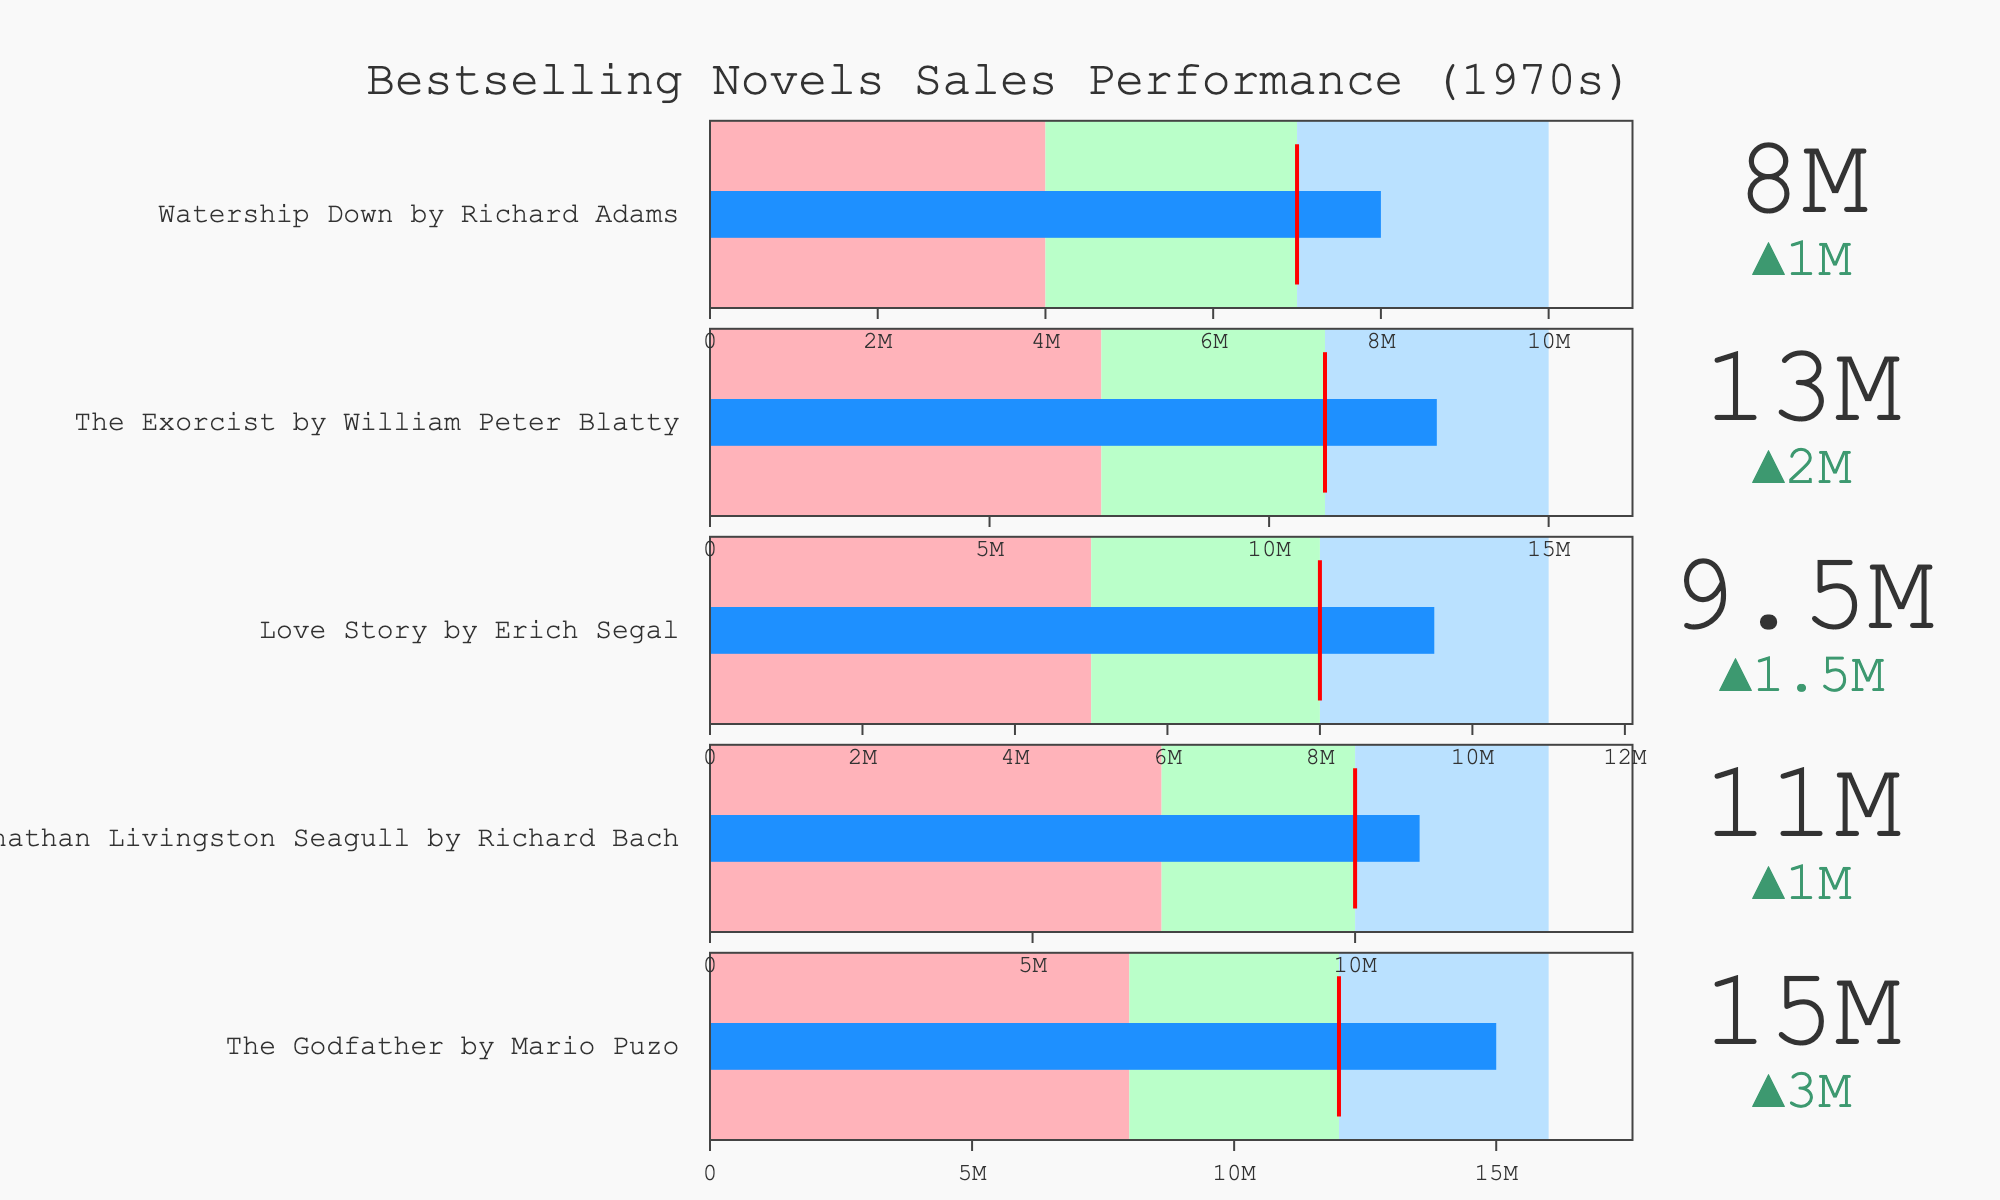What's the title of the chart? The title of the chart can be found at the top center; it reads "Bestselling Novels Sales Performance (1970s)".
Answer: Bestselling Novels Sales Performance (1970s) How many novels are displayed in the bullet chart? Each bullet chart represents one novel. By counting the number of bullet charts, we can find that there are five novels displayed.
Answer: Five Which novel exceeded its target sales by the largest amount? To determine this, look at the delta value in each bullet chart; the delta value shows how much the actual sales exceeded the target. "The Godfather" has the largest positive delta.
Answer: "The Godfather" What color indicates the "Good" performance range in the bullet charts? The "Good" performance range is shown by the third color band in each bullet chart. This color is light blue.
Answer: Light Blue Out of the five novels, which one had the lowest actual sales? To determine this, compare the actual sales value for each novel. "Watership Down" has the lowest actual sales at 8,000,000.
Answer: "Watership Down" Did "Love Story" by Erich Segal meet or exceed its target sales? To know this, compare the actual sales with the target. "Love Story" has actual sales of 9,500,000 and a target of 8,000,000, indicating it exceeded its target.
Answer: Exceeded What's the difference in actual sales between "Jonathan Livingston Seagull" and "The Exorcist"? To find the difference, subtract the actual sales of "The Exorcist" (13,000,000) from "Jonathan Livingston Seagull" (11,000,000). The difference is 2,000,000.
Answer: 2,000,000 Which novel's actual sales are closest to its "Good" performance threshold? To find this, compare the actual sales to the "Good" thresholds for each novel. "The Godfather" has actual sales (15,000,000) closest to its "Good" performance threshold (16,000,000).
Answer: "The Godfather" What color represents the "Poor" performance range in the bullet charts? The first color band in each bullet chart represents the "Poor" performance range. This color is light red.
Answer: Light Red Of the novels listed, which one had the smallest target sales goal? Look at the target sales value for each novel to determine which is smallest. "Watership Down" has the smallest target sales goal at 7,000,000.
Answer: "Watership Down" 